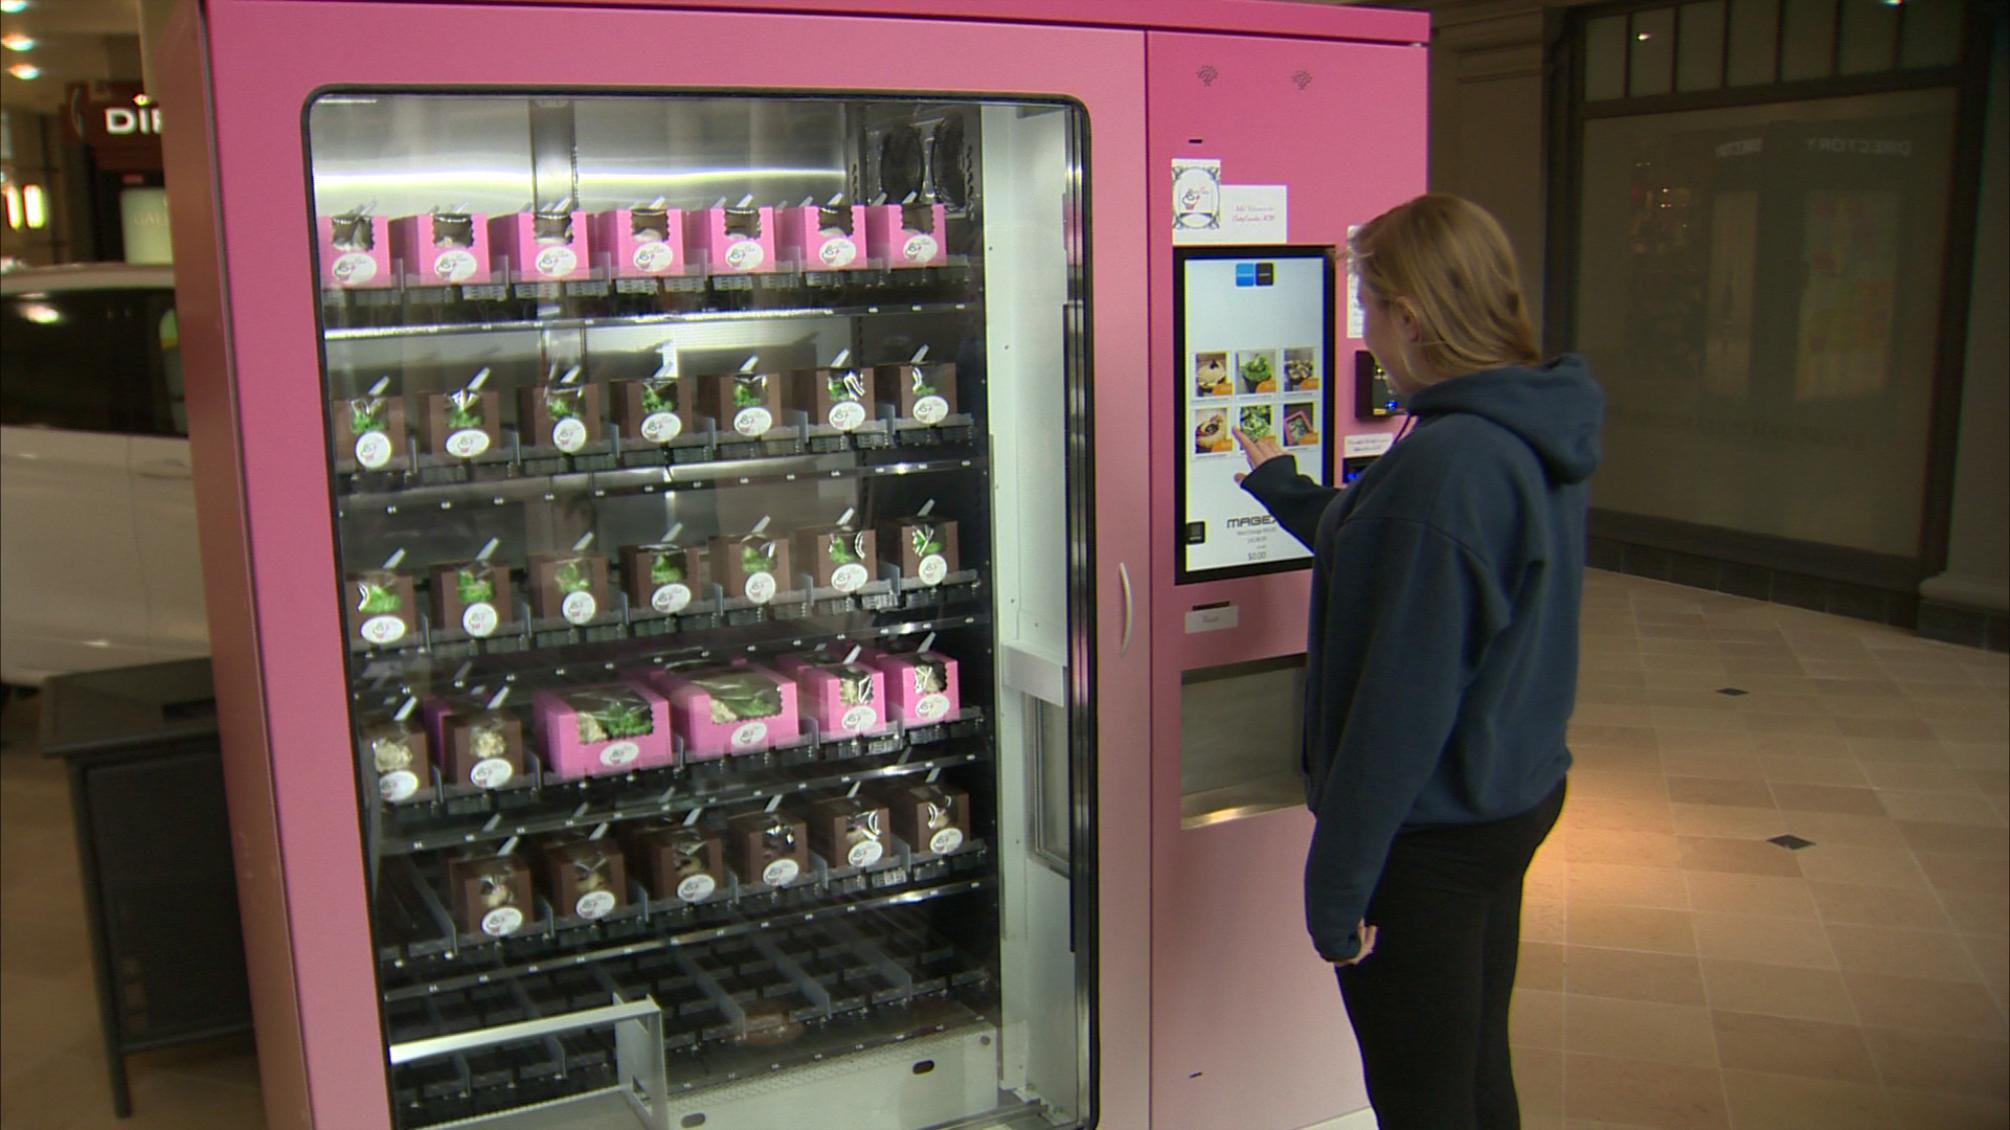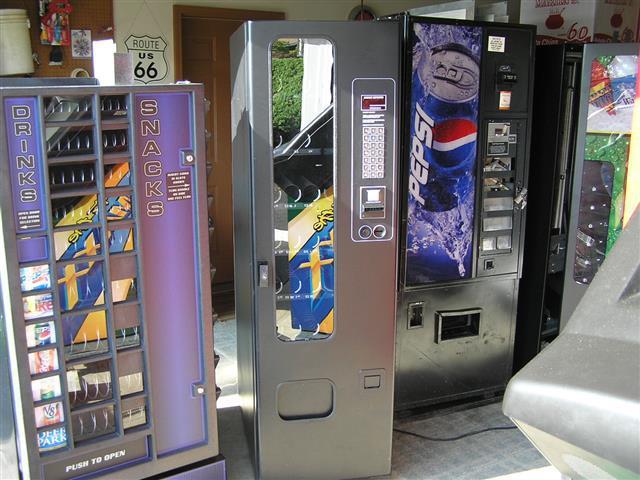The first image is the image on the left, the second image is the image on the right. Assess this claim about the two images: "In one image, a row of three vending machines are the same height.". Correct or not? Answer yes or no. No. 